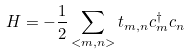Convert formula to latex. <formula><loc_0><loc_0><loc_500><loc_500>H = - \frac { 1 } { 2 } \sum _ { < m , n > } t _ { m , n } c _ { m } ^ { \dagger } c _ { n }</formula> 